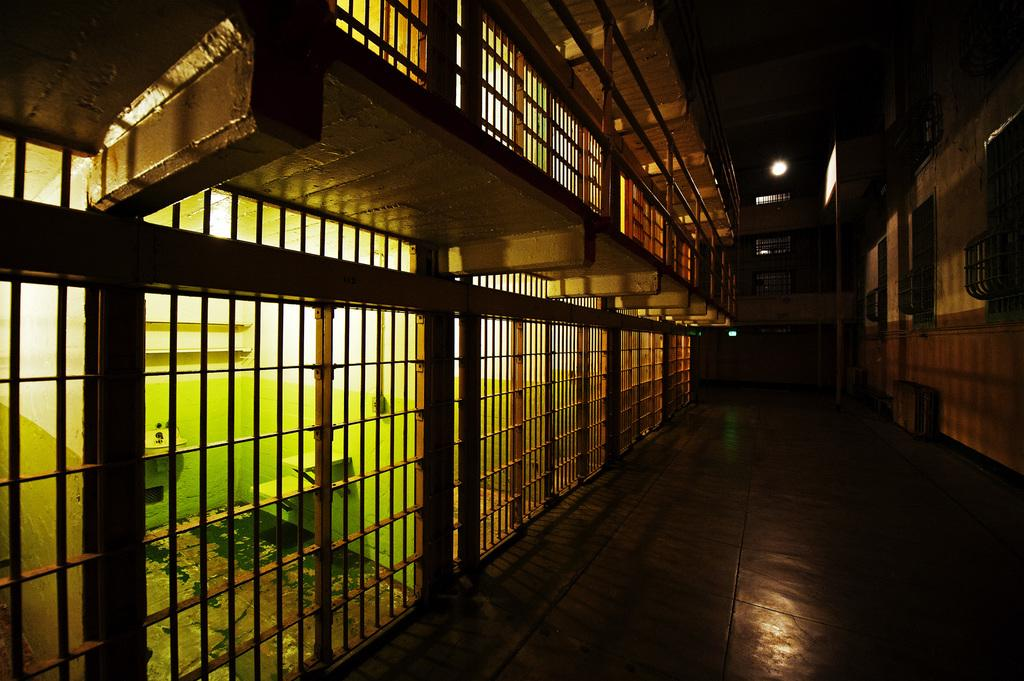What type of barrier can be seen in the image? There is a fence in the image. What other structure is present in the image? There is a wall in the image. What feature allows for visibility between the inside and outside of the structure? There are windows in the image. What source of illumination is visible in the image? There is a light in the image. Based on the presence of a hall, what type of setting might the image depict? The image may have been taken in a hall, which could be a part of a building or a public space. Can you see any grass growing in the image? There is no grass visible in the image. Is there a doctor present in the image? There is no doctor present in the image. 